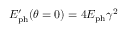<formula> <loc_0><loc_0><loc_500><loc_500>E _ { p h } ^ { \prime } ( \theta = 0 ) = 4 E _ { p h } \gamma ^ { 2 }</formula> 